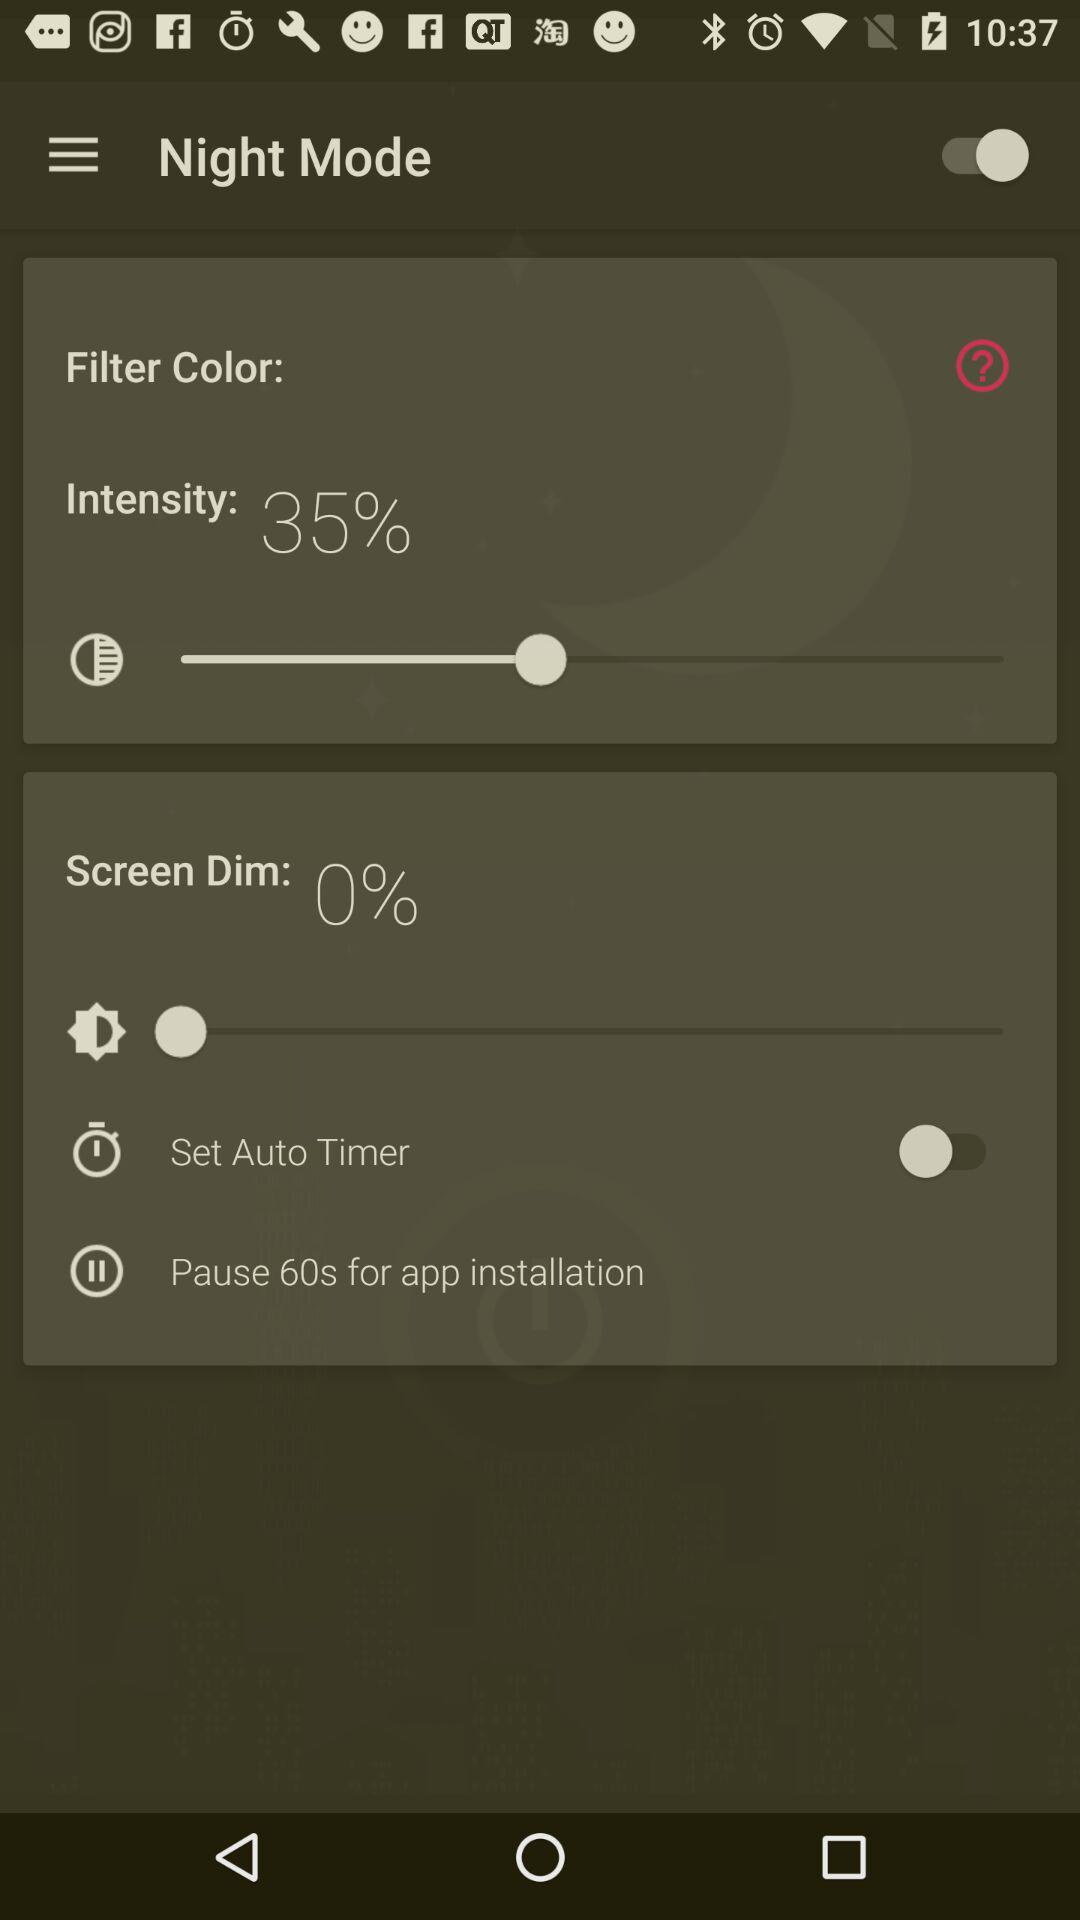How long does the auto timer pause for?
Answer the question using a single word or phrase. 60s 